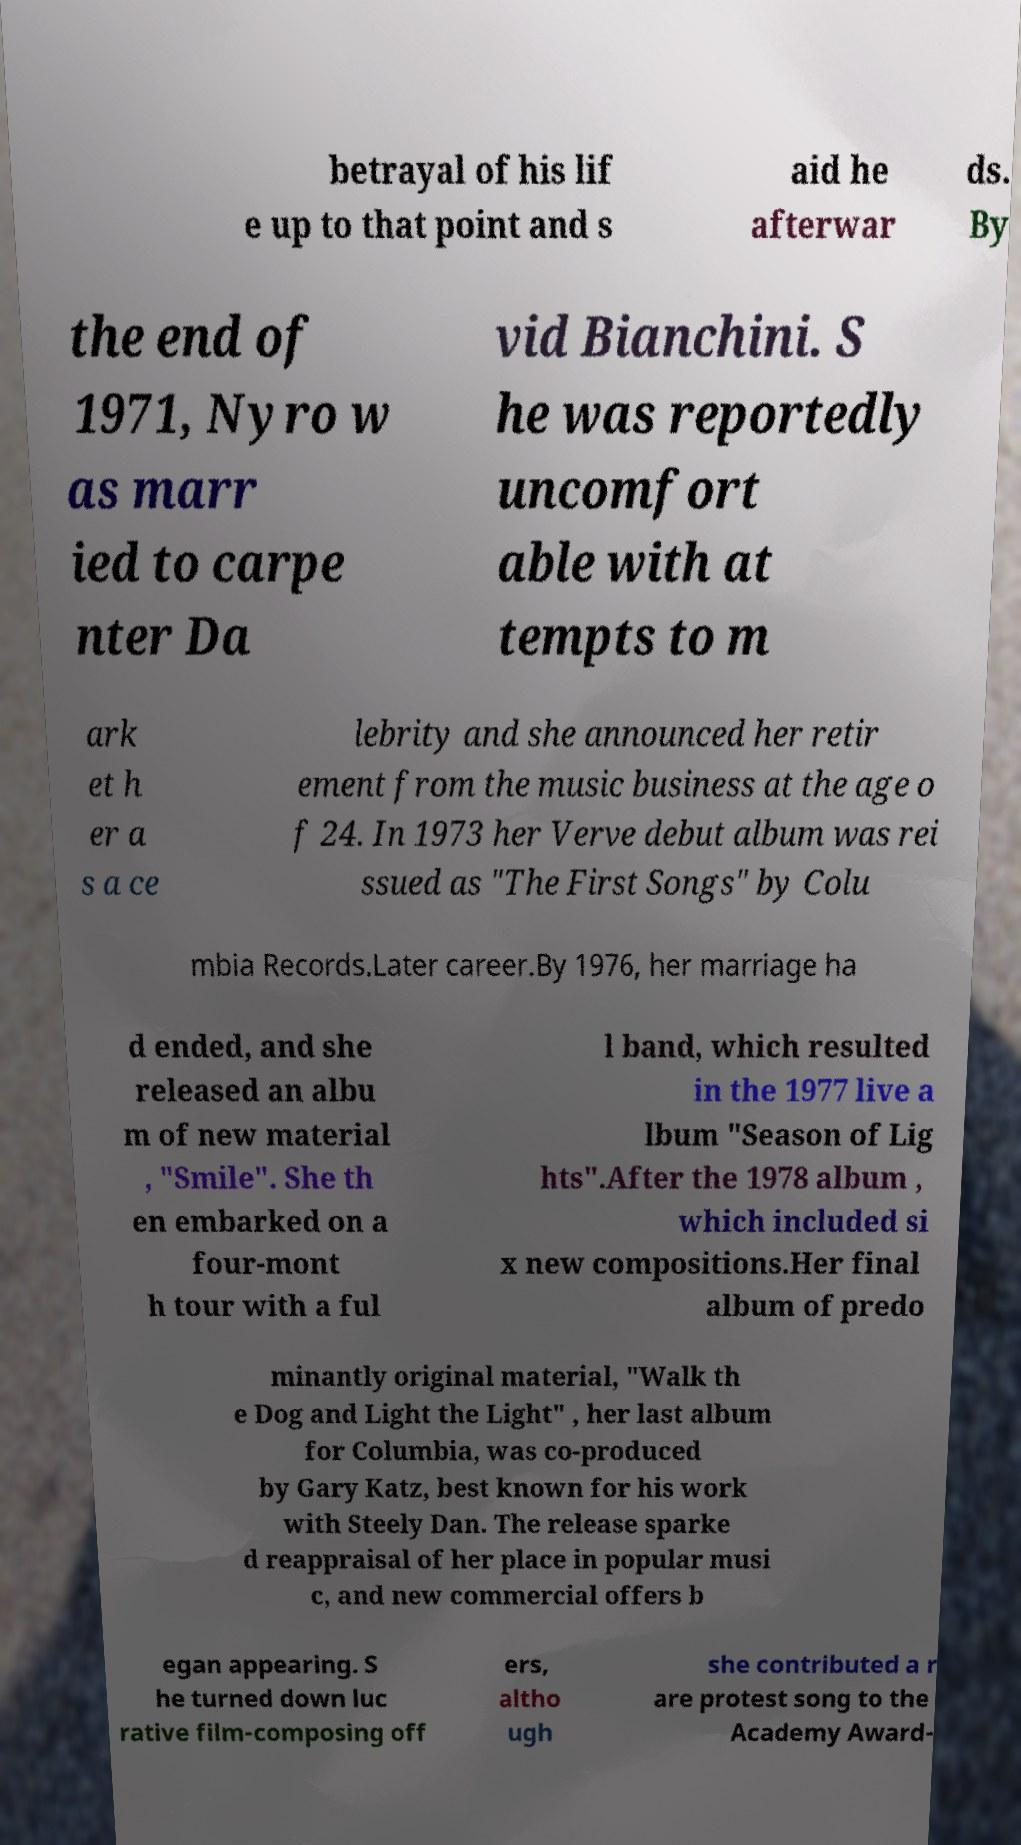For documentation purposes, I need the text within this image transcribed. Could you provide that? betrayal of his lif e up to that point and s aid he afterwar ds. By the end of 1971, Nyro w as marr ied to carpe nter Da vid Bianchini. S he was reportedly uncomfort able with at tempts to m ark et h er a s a ce lebrity and she announced her retir ement from the music business at the age o f 24. In 1973 her Verve debut album was rei ssued as "The First Songs" by Colu mbia Records.Later career.By 1976, her marriage ha d ended, and she released an albu m of new material , "Smile". She th en embarked on a four-mont h tour with a ful l band, which resulted in the 1977 live a lbum "Season of Lig hts".After the 1978 album , which included si x new compositions.Her final album of predo minantly original material, "Walk th e Dog and Light the Light" , her last album for Columbia, was co-produced by Gary Katz, best known for his work with Steely Dan. The release sparke d reappraisal of her place in popular musi c, and new commercial offers b egan appearing. S he turned down luc rative film-composing off ers, altho ugh she contributed a r are protest song to the Academy Award- 